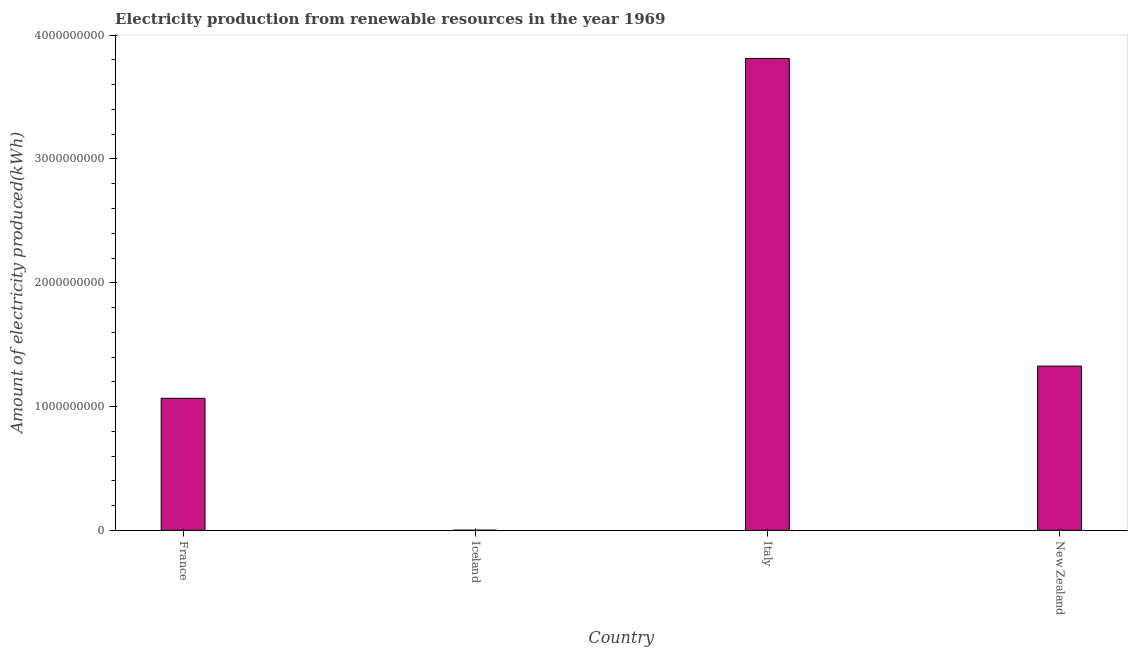Does the graph contain any zero values?
Provide a short and direct response. No. Does the graph contain grids?
Keep it short and to the point. No. What is the title of the graph?
Your response must be concise. Electricity production from renewable resources in the year 1969. What is the label or title of the X-axis?
Ensure brevity in your answer.  Country. What is the label or title of the Y-axis?
Your answer should be very brief. Amount of electricity produced(kWh). What is the amount of electricity produced in New Zealand?
Offer a terse response. 1.33e+09. Across all countries, what is the maximum amount of electricity produced?
Provide a short and direct response. 3.81e+09. Across all countries, what is the minimum amount of electricity produced?
Your answer should be very brief. 2.00e+06. In which country was the amount of electricity produced maximum?
Make the answer very short. Italy. In which country was the amount of electricity produced minimum?
Your answer should be very brief. Iceland. What is the sum of the amount of electricity produced?
Make the answer very short. 6.21e+09. What is the difference between the amount of electricity produced in Iceland and Italy?
Your answer should be very brief. -3.81e+09. What is the average amount of electricity produced per country?
Offer a very short reply. 1.55e+09. What is the median amount of electricity produced?
Offer a very short reply. 1.20e+09. In how many countries, is the amount of electricity produced greater than 3400000000 kWh?
Your answer should be very brief. 1. What is the ratio of the amount of electricity produced in Iceland to that in Italy?
Keep it short and to the point. 0. What is the difference between the highest and the second highest amount of electricity produced?
Your response must be concise. 2.48e+09. What is the difference between the highest and the lowest amount of electricity produced?
Your answer should be very brief. 3.81e+09. In how many countries, is the amount of electricity produced greater than the average amount of electricity produced taken over all countries?
Your response must be concise. 1. How many bars are there?
Offer a terse response. 4. Are all the bars in the graph horizontal?
Provide a succinct answer. No. How many countries are there in the graph?
Keep it short and to the point. 4. What is the difference between two consecutive major ticks on the Y-axis?
Provide a succinct answer. 1.00e+09. Are the values on the major ticks of Y-axis written in scientific E-notation?
Ensure brevity in your answer.  No. What is the Amount of electricity produced(kWh) of France?
Ensure brevity in your answer.  1.07e+09. What is the Amount of electricity produced(kWh) in Iceland?
Provide a succinct answer. 2.00e+06. What is the Amount of electricity produced(kWh) in Italy?
Provide a short and direct response. 3.81e+09. What is the Amount of electricity produced(kWh) in New Zealand?
Provide a short and direct response. 1.33e+09. What is the difference between the Amount of electricity produced(kWh) in France and Iceland?
Your response must be concise. 1.06e+09. What is the difference between the Amount of electricity produced(kWh) in France and Italy?
Give a very brief answer. -2.74e+09. What is the difference between the Amount of electricity produced(kWh) in France and New Zealand?
Your answer should be compact. -2.60e+08. What is the difference between the Amount of electricity produced(kWh) in Iceland and Italy?
Your answer should be very brief. -3.81e+09. What is the difference between the Amount of electricity produced(kWh) in Iceland and New Zealand?
Your answer should be very brief. -1.32e+09. What is the difference between the Amount of electricity produced(kWh) in Italy and New Zealand?
Your answer should be very brief. 2.48e+09. What is the ratio of the Amount of electricity produced(kWh) in France to that in Iceland?
Your answer should be compact. 533.5. What is the ratio of the Amount of electricity produced(kWh) in France to that in Italy?
Your answer should be compact. 0.28. What is the ratio of the Amount of electricity produced(kWh) in France to that in New Zealand?
Keep it short and to the point. 0.8. What is the ratio of the Amount of electricity produced(kWh) in Iceland to that in Italy?
Keep it short and to the point. 0. What is the ratio of the Amount of electricity produced(kWh) in Iceland to that in New Zealand?
Give a very brief answer. 0. What is the ratio of the Amount of electricity produced(kWh) in Italy to that in New Zealand?
Your answer should be compact. 2.87. 